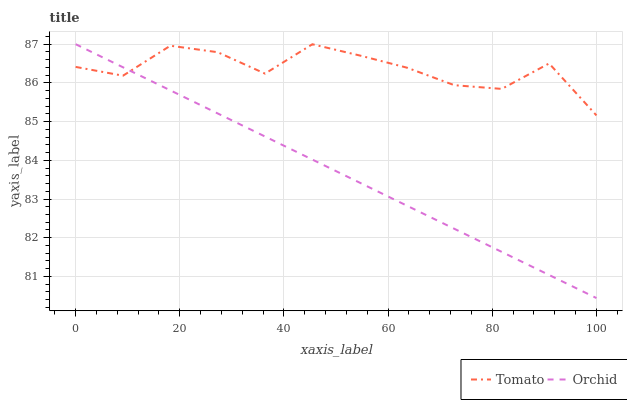Does Orchid have the maximum area under the curve?
Answer yes or no. No. Is Orchid the roughest?
Answer yes or no. No. 